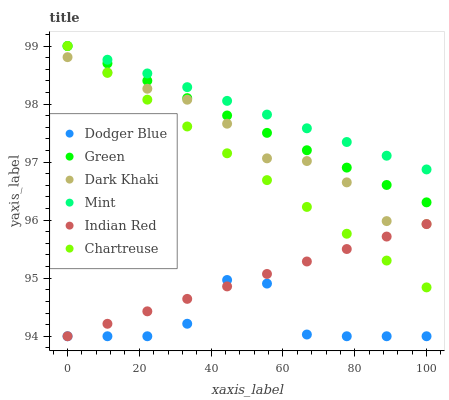Does Dodger Blue have the minimum area under the curve?
Answer yes or no. Yes. Does Mint have the maximum area under the curve?
Answer yes or no. Yes. Does Chartreuse have the minimum area under the curve?
Answer yes or no. No. Does Chartreuse have the maximum area under the curve?
Answer yes or no. No. Is Indian Red the smoothest?
Answer yes or no. Yes. Is Dodger Blue the roughest?
Answer yes or no. Yes. Is Chartreuse the smoothest?
Answer yes or no. No. Is Chartreuse the roughest?
Answer yes or no. No. Does Indian Red have the lowest value?
Answer yes or no. Yes. Does Chartreuse have the lowest value?
Answer yes or no. No. Does Mint have the highest value?
Answer yes or no. Yes. Does Indian Red have the highest value?
Answer yes or no. No. Is Dodger Blue less than Chartreuse?
Answer yes or no. Yes. Is Mint greater than Dodger Blue?
Answer yes or no. Yes. Does Chartreuse intersect Mint?
Answer yes or no. Yes. Is Chartreuse less than Mint?
Answer yes or no. No. Is Chartreuse greater than Mint?
Answer yes or no. No. Does Dodger Blue intersect Chartreuse?
Answer yes or no. No. 